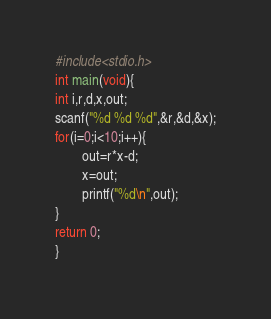<code> <loc_0><loc_0><loc_500><loc_500><_C_>#include<stdio.h>
int main(void){
int i,r,d,x,out;
scanf("%d %d %d",&r,&d,&x);
for(i=0;i<10;i++){
        out=r*x-d;
        x=out;
        printf("%d\n",out);
}
return 0;
}</code> 